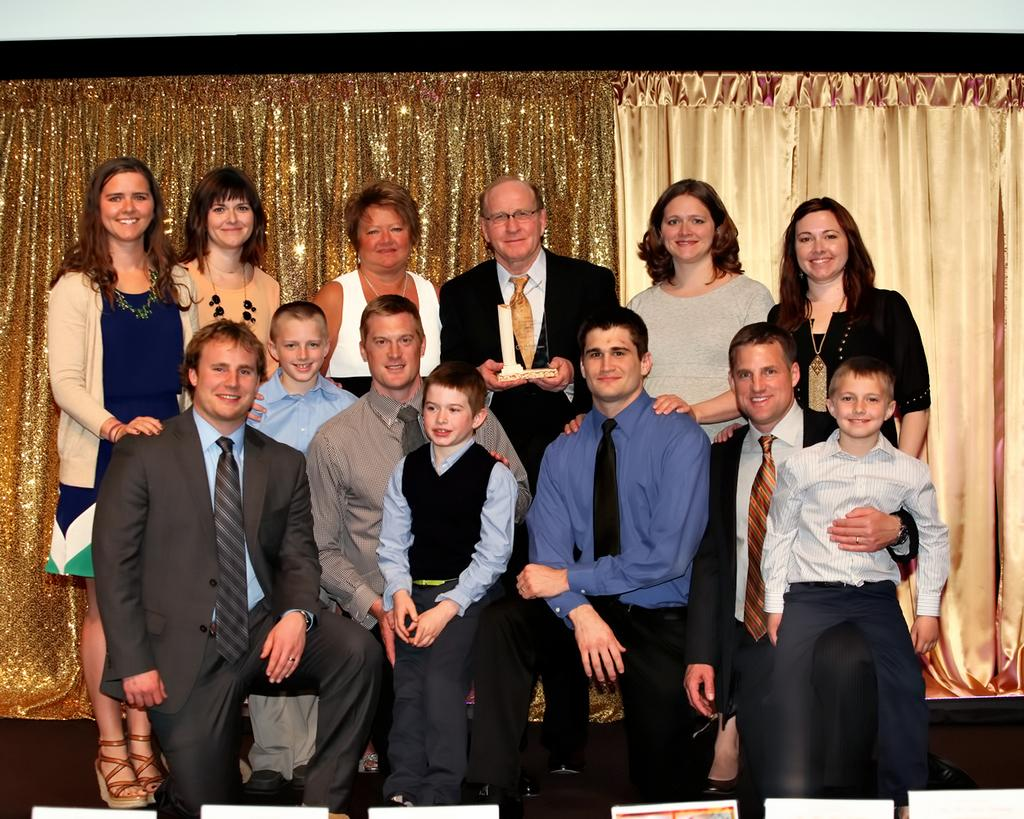How many people are in the image? There are people in the image, but the exact number is not specified. What is the facial expression of some people in the image? Some people in the image are smiling. How are the people in the first row positioned? The people in the first row are sitting in a squat position. Are there people standing in the image? Yes, there are people standing in the image. Can you describe the interaction between the boy and the man? A boy is sitting on a man. What can be seen in the background of the image? There are curtains in the background of the image. What is the distance between the pump and the scene in the image? There is no pump or scene present in the image, so it is not possible to determine the distance between them. 